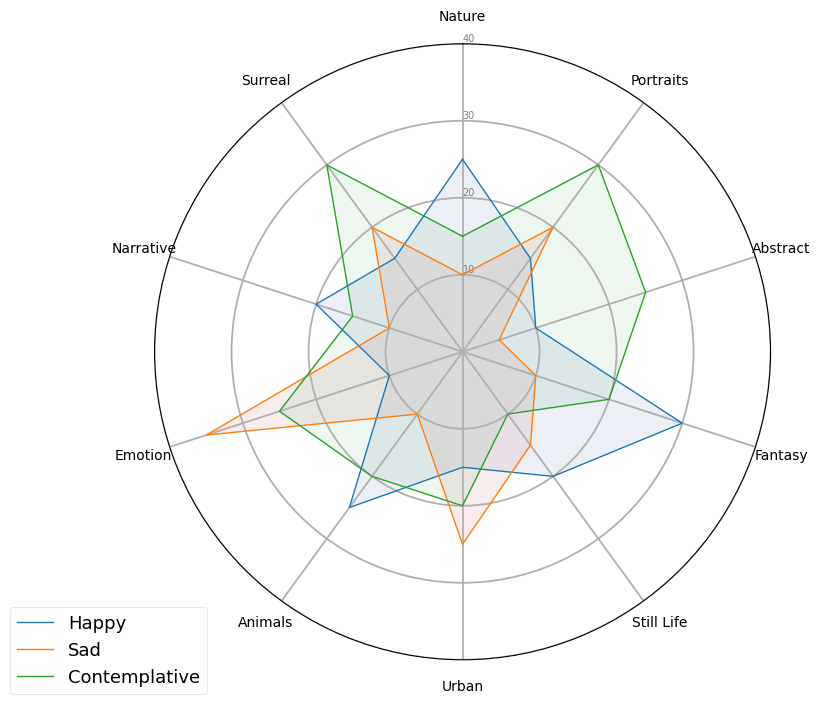Which theme has the highest number of sketches with a happy tone? By visually inspecting the figure, look for the segment with the highest peak in the "Happy" section, which is colored in blue.
Answer: Fantasy Which theme has the lowest number of sketches with a sad tone? Check for the segment with the shortest peak in the "Sad" section, colored in red.
Answer: Abstract What's the sum of "Happy" sketches for both "Nature" and "Urban" themes? Add the "Happy" values for "Nature" (25) and "Urban" (15): 25 + 15 = 40.
Answer: 40 Is "Contemplative" the dominant emotional tone for "Portraits"? Compare the heights of the "Happy", "Sad", and "Contemplative" segments of the "Portraits" theme. The "Contemplative" section is the highest.
Answer: Yes Which theme has a higher number of "Sad" sketches, "Still Life" or "Surreal"? Compare the heights of the "Sad" sections for "Still Life" and "Surreal" themes. The "Sad" section for "Surreal" is higher.
Answer: Surreal What's the average number of "Sad" sketches across all themes? Sum up all the "Sad" values: 10 (Nature) + 20 (Portraits) + 5 (Abstract) + 10 (Fantasy) + 15 (Still Life) + 25 (Urban) + 10 (Animals) + 35 (Emotion) + 10 (Narrative) + 20 (Surreal) = 160. Divide by the number of themes (10): 160 / 10 = 16.
Answer: 16 Which has more "Contemplative" sketches, "Fantasy" or "Animals"? Compare the heights of the "Contemplative" sections for "Fantasy" and "Animals." The "Contemplative" section for "Animals" is higher.
Answer: Animals How many more "Happy" sketches does "Fantasy" have compared to "Abstract"? Subtract the "Happy" value for "Abstract" (10) from "Fantasy" (30): 30 - 10 = 20.
Answer: 20 Which theme has the most balanced number of sketches across all three emotional tones? Look for a theme where the three emotional-tone segments (blue, red, green) are close in height.
Answer: Still Life 